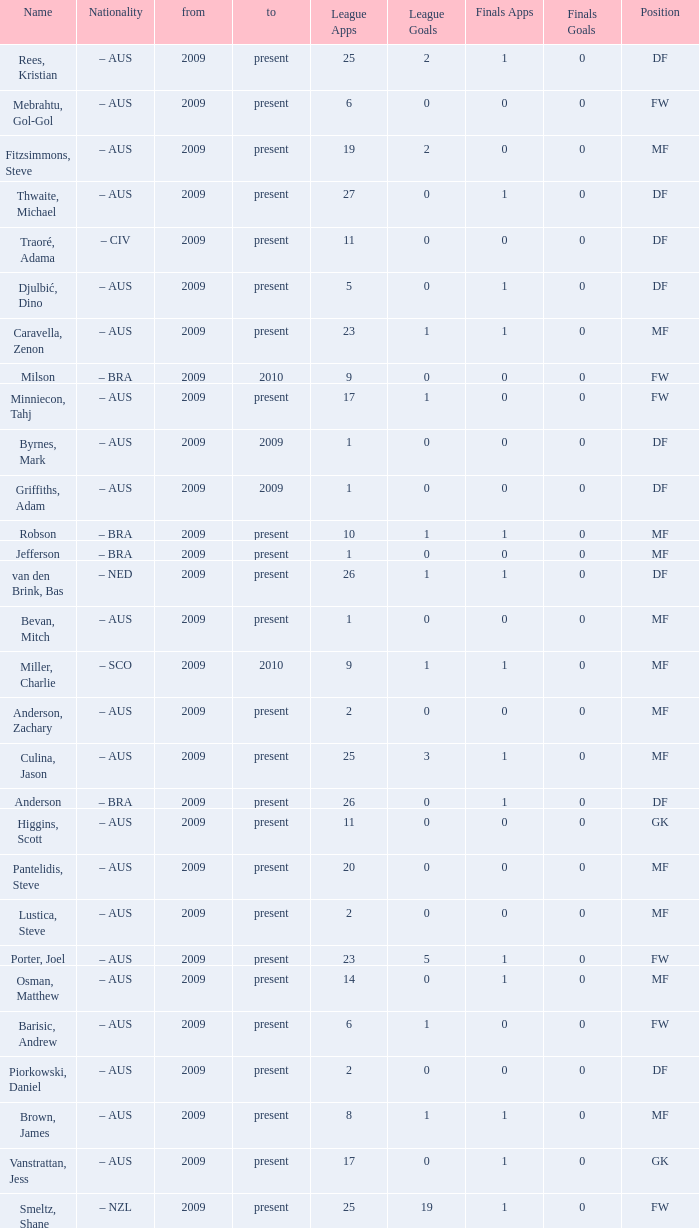Name the mosst finals apps 1.0. 